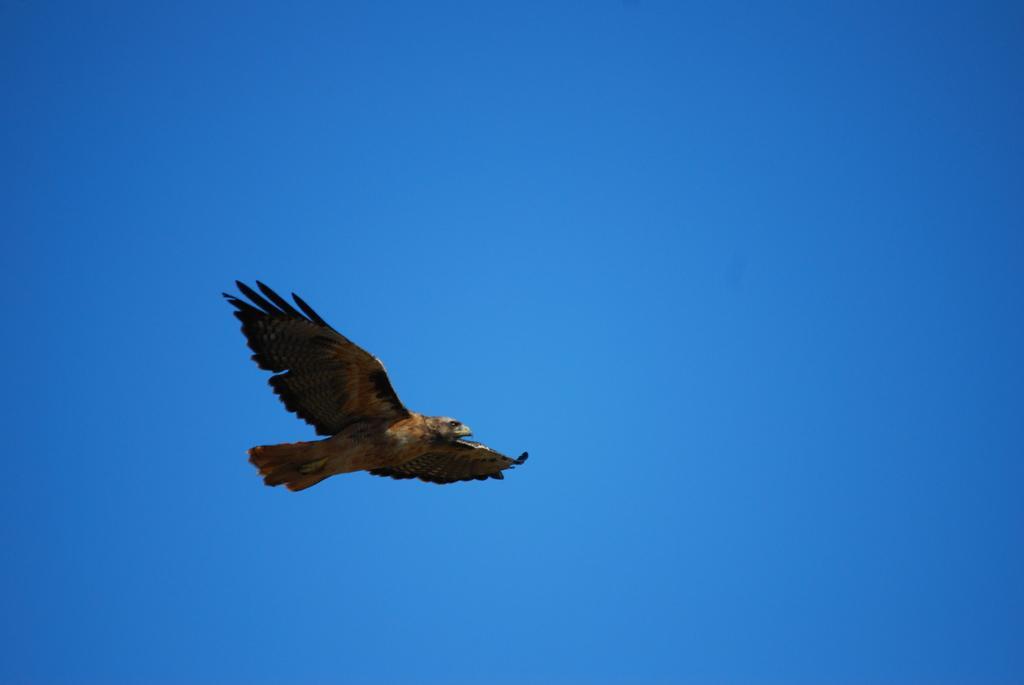How would you summarize this image in a sentence or two? In this picture we can see an eagle which is flying in the sky. 